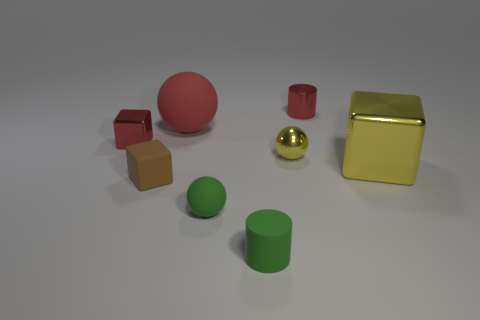Subtract 1 blocks. How many blocks are left? 2 Add 1 tiny brown matte objects. How many objects exist? 9 Subtract all balls. How many objects are left? 5 Subtract 0 brown balls. How many objects are left? 8 Subtract all brown rubber things. Subtract all large metallic spheres. How many objects are left? 7 Add 2 red spheres. How many red spheres are left? 3 Add 3 tiny metallic balls. How many tiny metallic balls exist? 4 